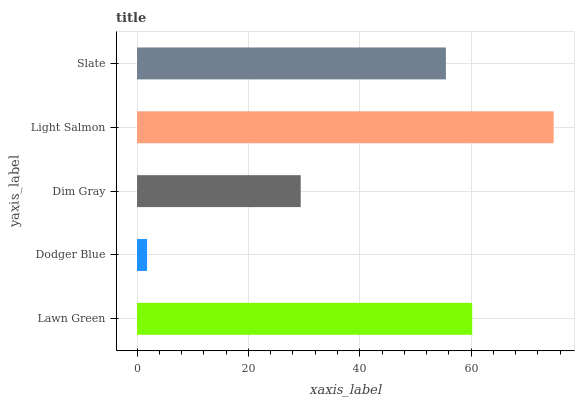Is Dodger Blue the minimum?
Answer yes or no. Yes. Is Light Salmon the maximum?
Answer yes or no. Yes. Is Dim Gray the minimum?
Answer yes or no. No. Is Dim Gray the maximum?
Answer yes or no. No. Is Dim Gray greater than Dodger Blue?
Answer yes or no. Yes. Is Dodger Blue less than Dim Gray?
Answer yes or no. Yes. Is Dodger Blue greater than Dim Gray?
Answer yes or no. No. Is Dim Gray less than Dodger Blue?
Answer yes or no. No. Is Slate the high median?
Answer yes or no. Yes. Is Slate the low median?
Answer yes or no. Yes. Is Lawn Green the high median?
Answer yes or no. No. Is Lawn Green the low median?
Answer yes or no. No. 